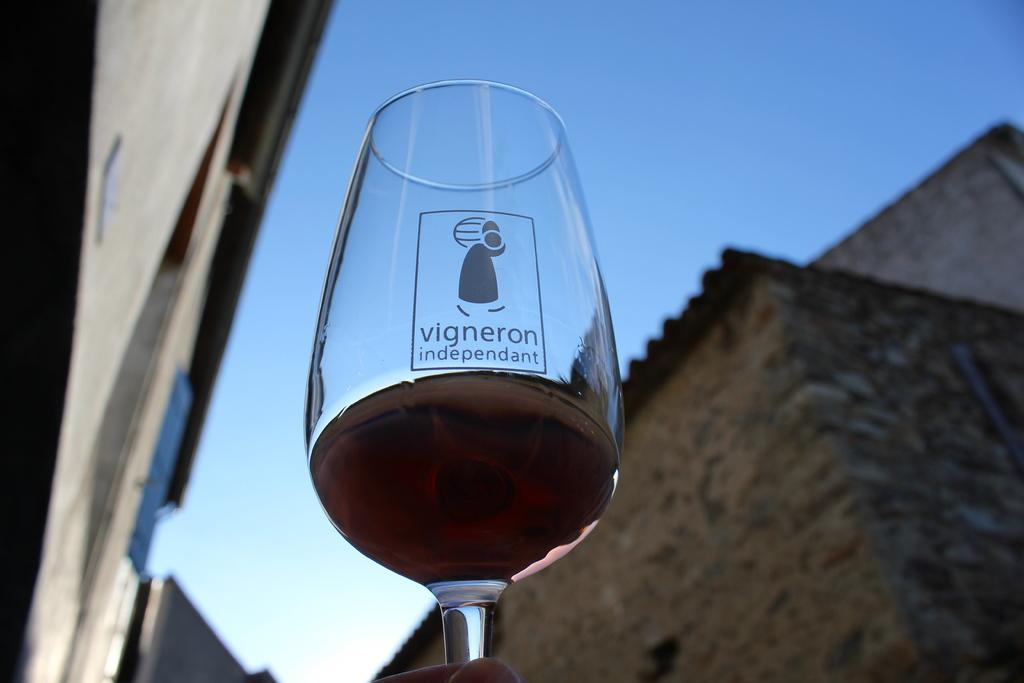What object is present in the image that is typically used for drinking? There is a wine glass in the image. What is inside the wine glass? The wine glass contains some liquid. Who is holding the wine glass in the image? A person's hand is holding the wine glass. What can be seen in the distance in the image? There are buildings visible in the background of the image. What part of the natural environment is visible in the image? The sky is visible in the background of the image. What year is depicted on the iron in the image? There is no iron present in the image, and therefore no year can be found on it. 